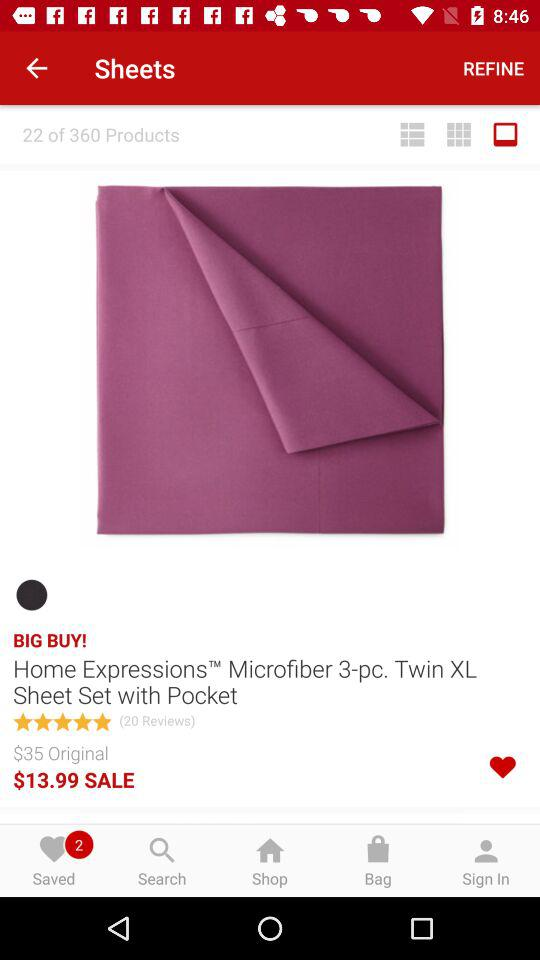What is the total number of products? The total number of products is 360. 